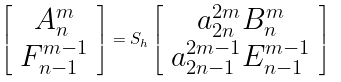<formula> <loc_0><loc_0><loc_500><loc_500>\left [ \begin{array} { c c } A _ { n } ^ { m } \\ F _ { n - 1 } ^ { m - 1 } \end{array} \right ] = S _ { h } \left [ \begin{array} { c c } a _ { 2 n } ^ { 2 m } B _ { n } ^ { m } \\ a _ { 2 n - 1 } ^ { 2 m - 1 } E _ { n - 1 } ^ { m - 1 } \end{array} \right ]</formula> 